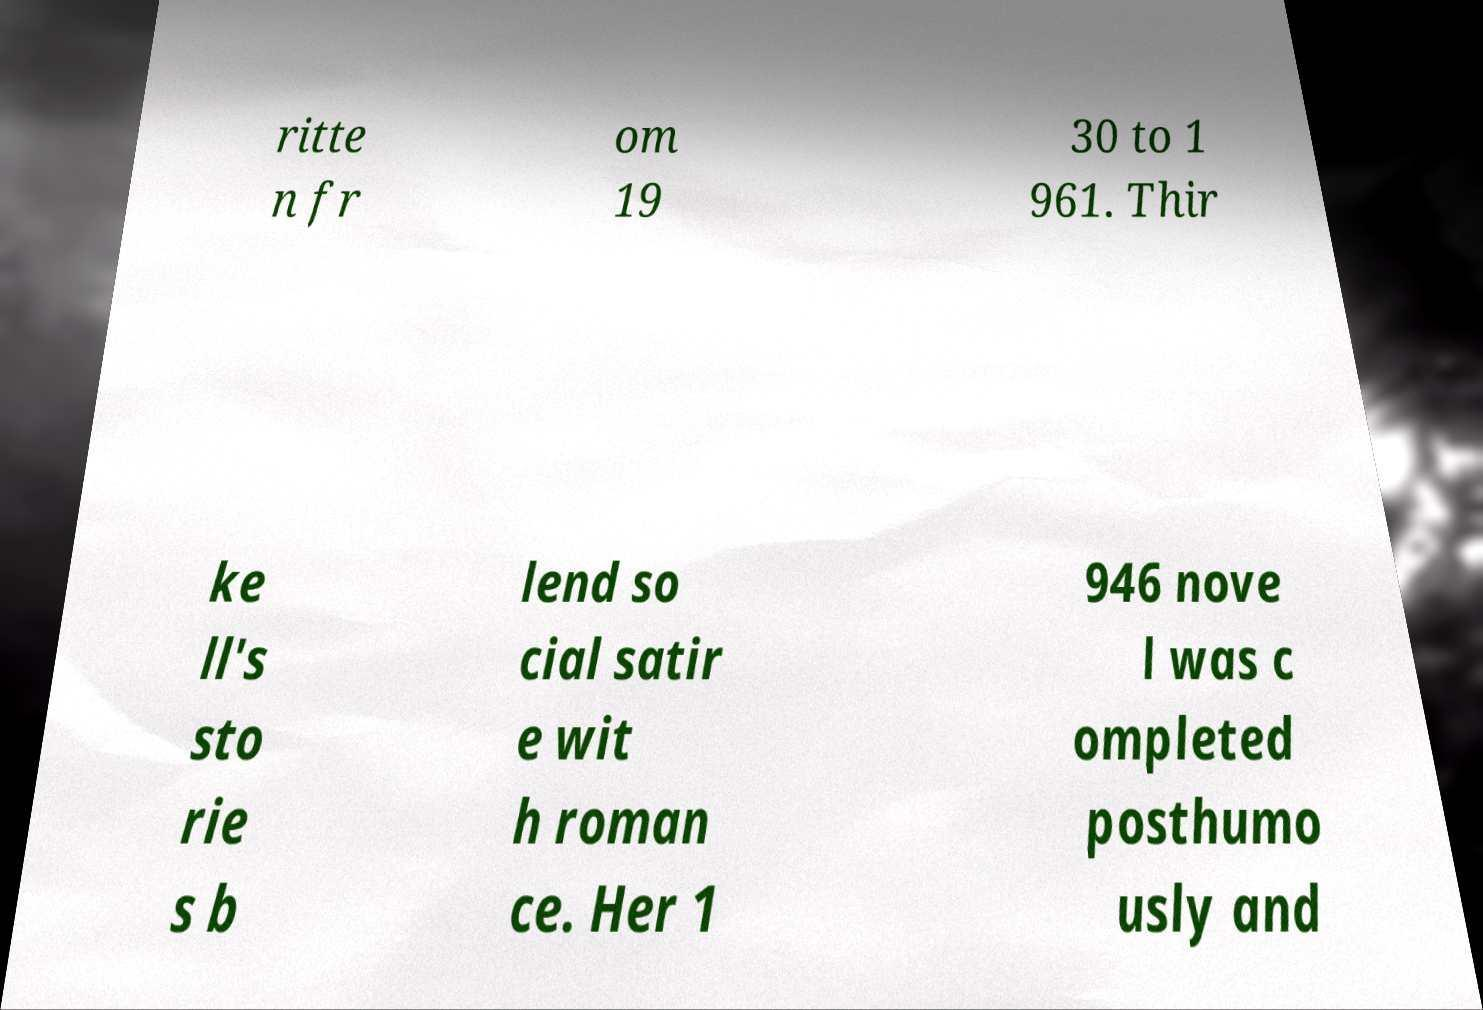What messages or text are displayed in this image? I need them in a readable, typed format. ritte n fr om 19 30 to 1 961. Thir ke ll's sto rie s b lend so cial satir e wit h roman ce. Her 1 946 nove l was c ompleted posthumo usly and 